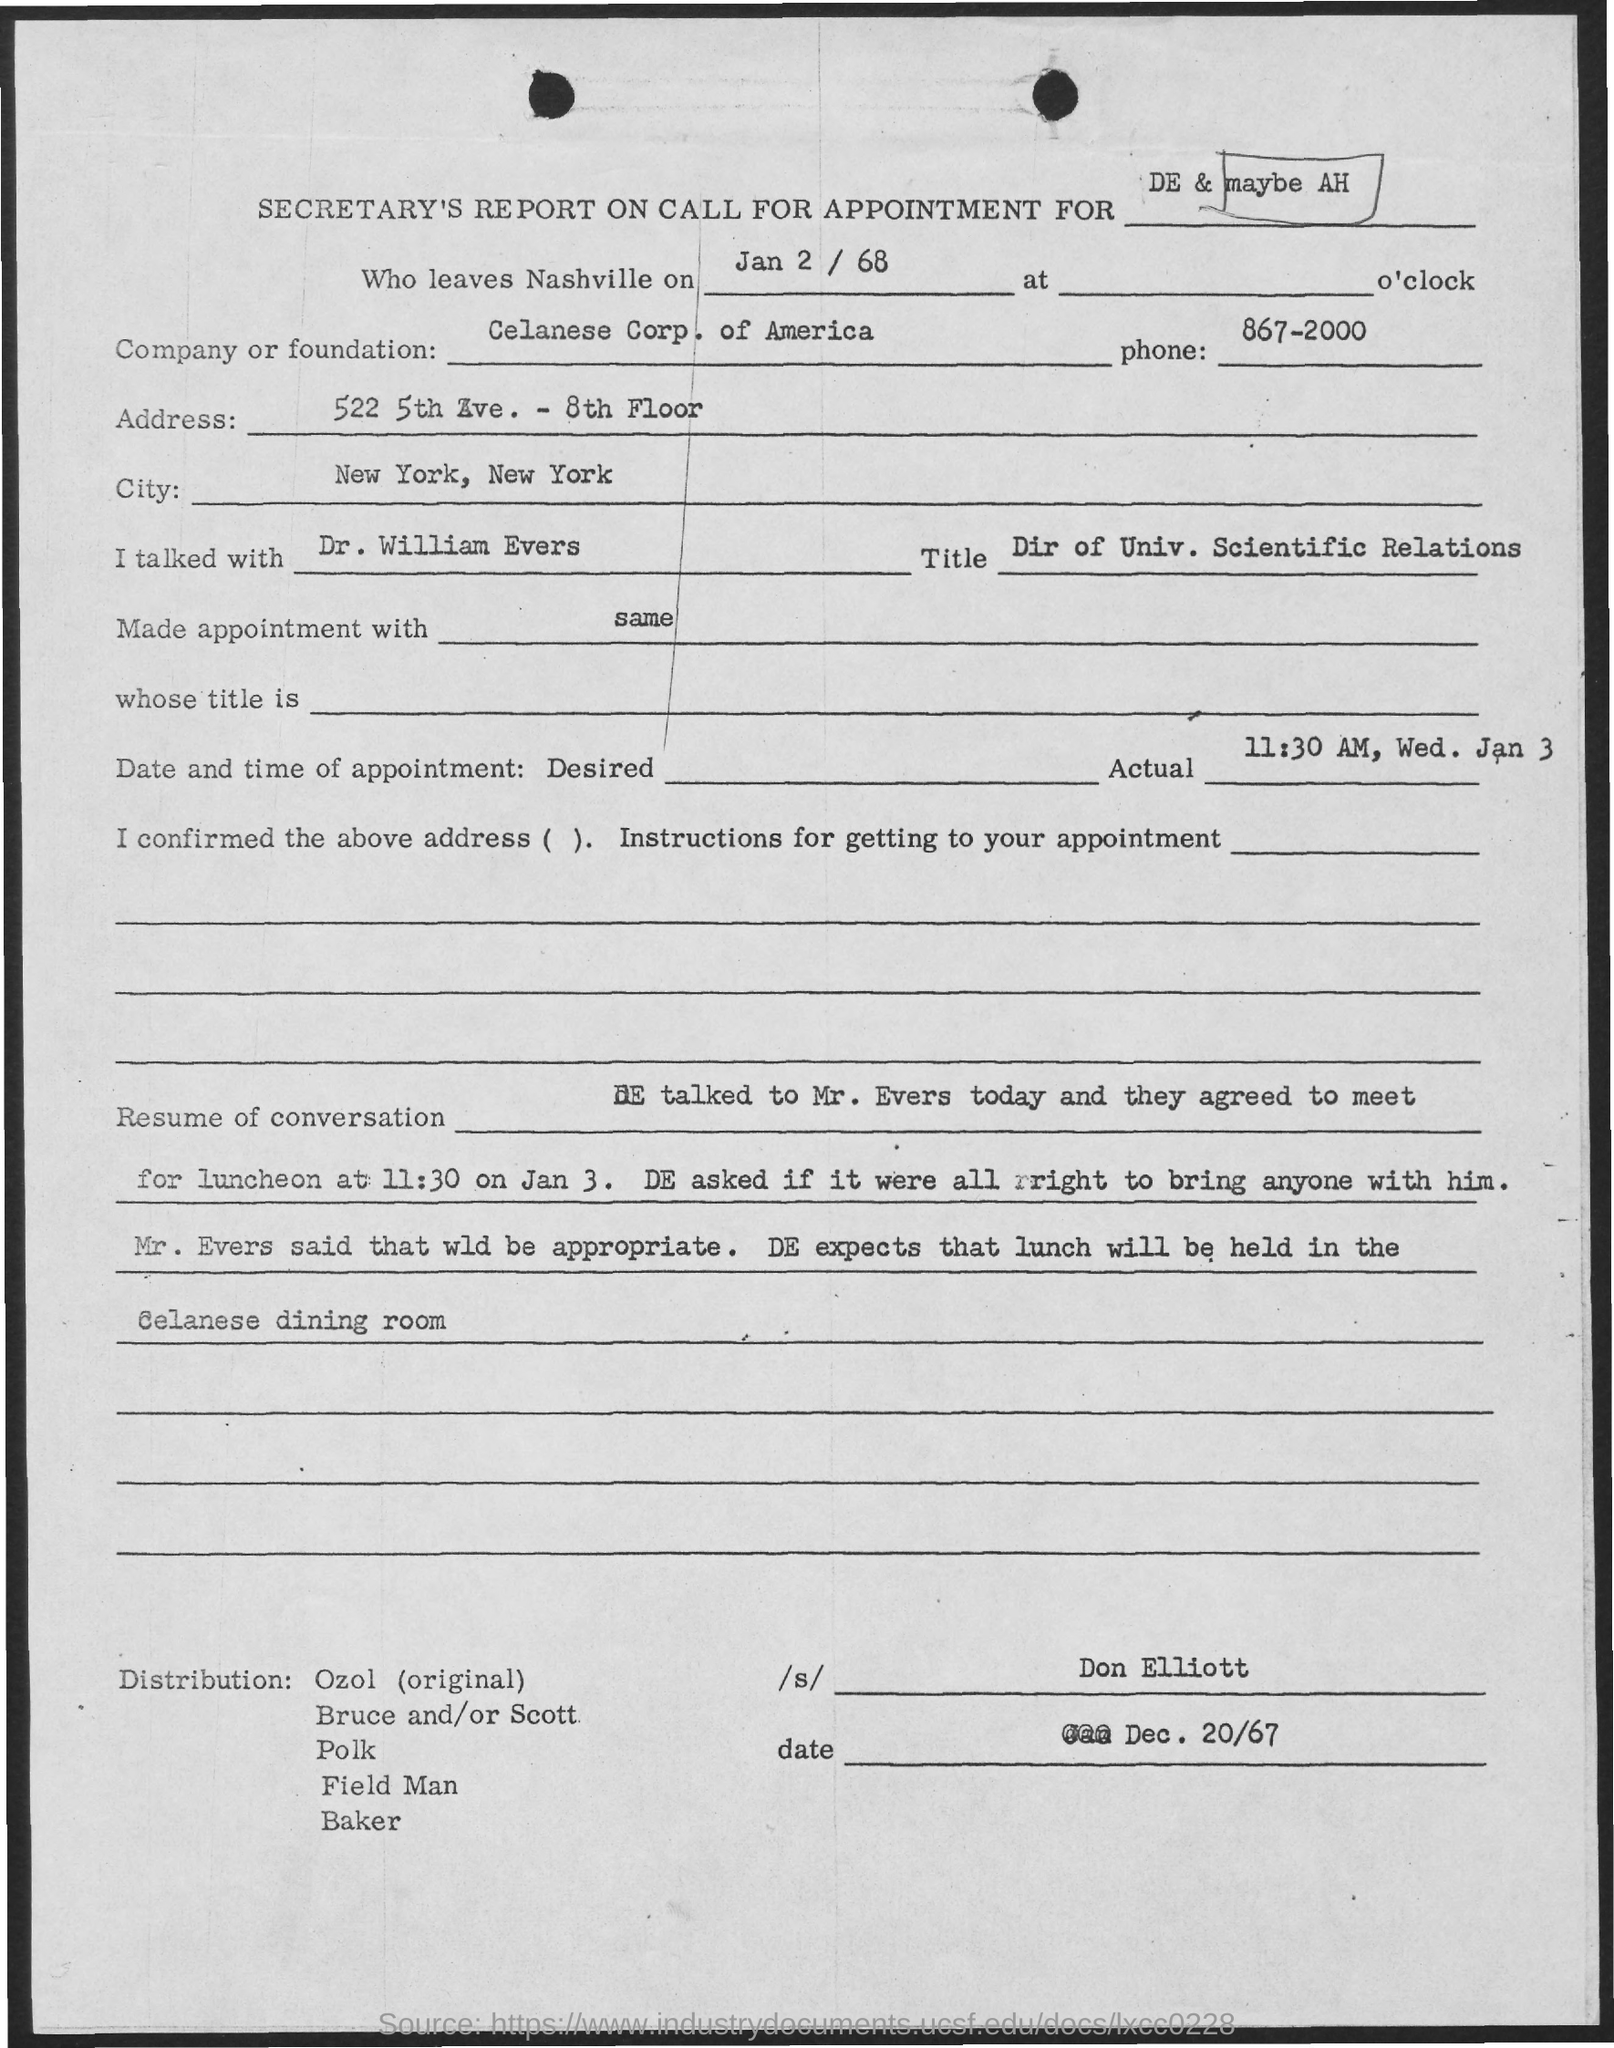When do they leave Nashville?
Give a very brief answer. Jan 2 / 68. Which is the Company or Foundation?
Give a very brief answer. Celanese Corp of America. What is the Phone?
Offer a very short reply. 867-2000. What is the Address?
Your answer should be very brief. 522 5th Ave. - 8th Floor. Which is the City?
Your response must be concise. New York, New York. What is the Date and Time of the Appointment?
Your response must be concise. 11:30 AM, Wed. Jan 3. 